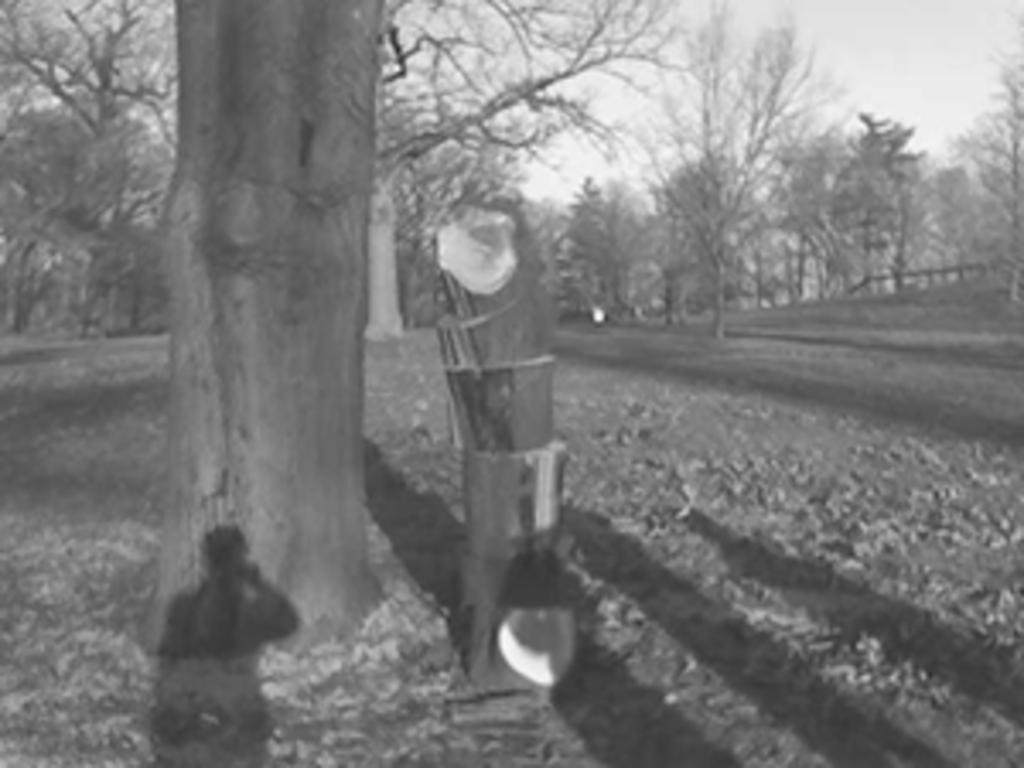In one or two sentences, can you explain what this image depicts? There is a black and white image. In this image, there is an outside view. In the foreground, there is a tree stem. In the background, there are some trees. 